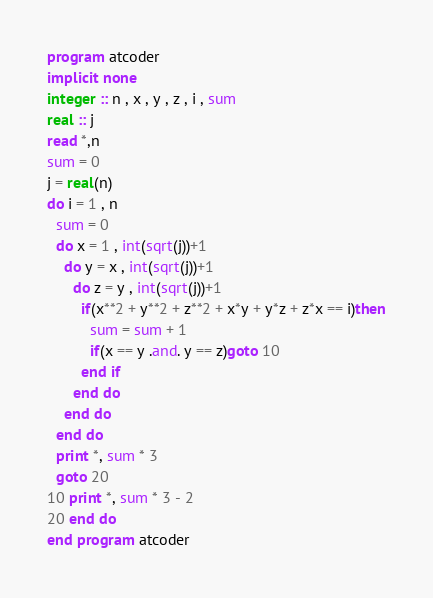<code> <loc_0><loc_0><loc_500><loc_500><_FORTRAN_>program atcoder
implicit none
integer :: n , x , y , z , i , sum
real :: j
read *,n
sum = 0
j = real(n)
do i = 1 , n
  sum = 0
  do x = 1 , int(sqrt(j))+1
    do y = x , int(sqrt(j))+1
      do z = y , int(sqrt(j))+1
        if(x**2 + y**2 + z**2 + x*y + y*z + z*x == i)then
          sum = sum + 1
          if(x == y .and. y == z)goto 10
        end if
      end do
    end do
  end do
  print *, sum * 3
  goto 20
10 print *, sum * 3 - 2
20 end do
end program atcoder
</code> 